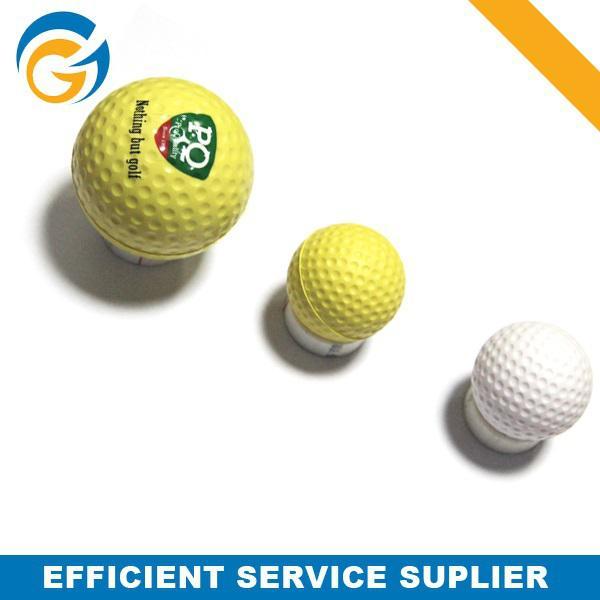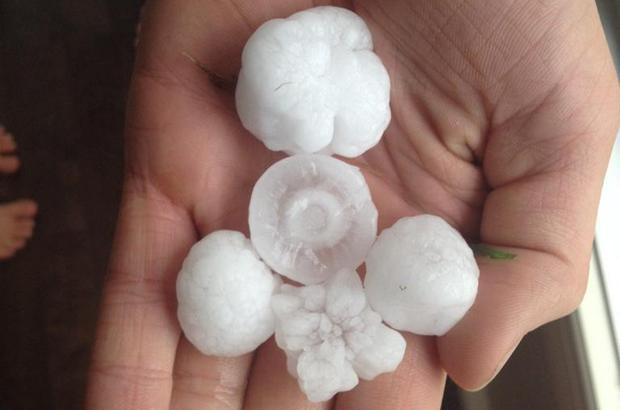The first image is the image on the left, the second image is the image on the right. Evaluate the accuracy of this statement regarding the images: "One image shows a pyramid shape formed by three golf balls, and the other image contains no more than one golf ball.". Is it true? Answer yes or no. No. The first image is the image on the left, the second image is the image on the right. Evaluate the accuracy of this statement regarding the images: "The right image contains exactly three golf balls in a triangular formation.". Is it true? Answer yes or no. No. 